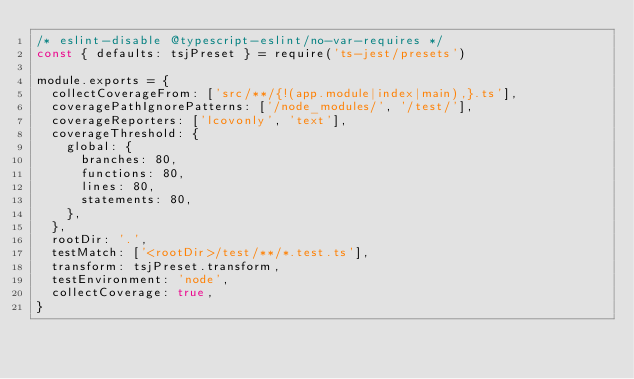Convert code to text. <code><loc_0><loc_0><loc_500><loc_500><_JavaScript_>/* eslint-disable @typescript-eslint/no-var-requires */
const { defaults: tsjPreset } = require('ts-jest/presets')

module.exports = {
  collectCoverageFrom: ['src/**/{!(app.module|index|main),}.ts'],
  coveragePathIgnorePatterns: ['/node_modules/', '/test/'],
  coverageReporters: ['lcovonly', 'text'],
  coverageThreshold: {
    global: {
      branches: 80,
      functions: 80,
      lines: 80,
      statements: 80,
    },
  },
  rootDir: '.',
  testMatch: ['<rootDir>/test/**/*.test.ts'],
  transform: tsjPreset.transform,
  testEnvironment: 'node',
  collectCoverage: true,
}
</code> 